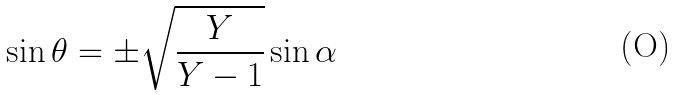<formula> <loc_0><loc_0><loc_500><loc_500>\sin \theta = \pm \sqrt { \frac { Y } { Y - 1 } } \sin \alpha</formula> 